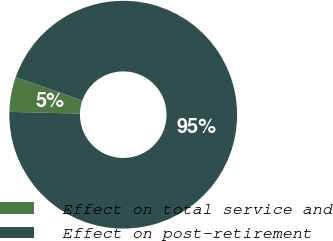<chart> <loc_0><loc_0><loc_500><loc_500><pie_chart><fcel>Effect on total service and<fcel>Effect on post-retirement<nl><fcel>4.95%<fcel>95.05%<nl></chart> 